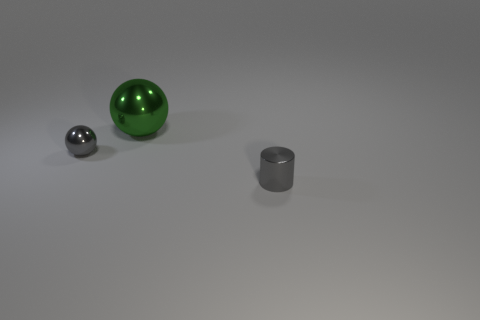There is a gray thing to the left of the metallic cylinder; does it have the same size as the small cylinder?
Offer a very short reply. Yes. There is a shiny thing that is both in front of the big metallic object and behind the small cylinder; what color is it?
Make the answer very short. Gray. There is a shiny object to the left of the large shiny sphere; how many green shiny balls are on the left side of it?
Offer a very short reply. 0. Is there any other thing of the same color as the large metal ball?
Give a very brief answer. No. There is a green metal thing; does it have the same shape as the small gray thing right of the green metallic object?
Provide a succinct answer. No. What color is the small object that is in front of the small gray thing that is on the left side of the gray object in front of the gray ball?
Keep it short and to the point. Gray. Is there anything else that is the same material as the cylinder?
Provide a succinct answer. Yes. There is a object that is right of the big sphere; is its shape the same as the large metallic thing?
Your response must be concise. No. What is the material of the small ball?
Offer a very short reply. Metal. What shape is the gray metallic thing that is in front of the gray metallic thing that is behind the tiny gray object right of the green ball?
Offer a very short reply. Cylinder. 